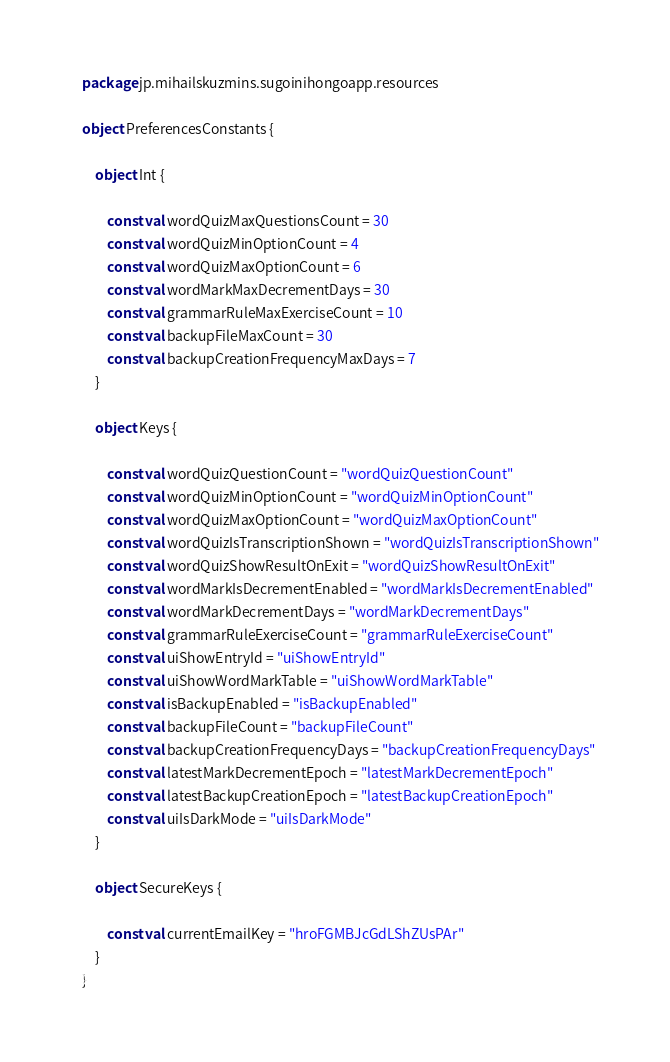Convert code to text. <code><loc_0><loc_0><loc_500><loc_500><_Kotlin_>package jp.mihailskuzmins.sugoinihongoapp.resources

object PreferencesConstants {

	object Int {

		const val wordQuizMaxQuestionsCount = 30
		const val wordQuizMinOptionCount = 4
		const val wordQuizMaxOptionCount = 6
		const val wordMarkMaxDecrementDays = 30
		const val grammarRuleMaxExerciseCount = 10
		const val backupFileMaxCount = 30
		const val backupCreationFrequencyMaxDays = 7
	}

	object Keys {

		const val wordQuizQuestionCount = "wordQuizQuestionCount"
		const val wordQuizMinOptionCount = "wordQuizMinOptionCount"
		const val wordQuizMaxOptionCount = "wordQuizMaxOptionCount"
		const val wordQuizIsTranscriptionShown = "wordQuizIsTranscriptionShown"
		const val wordQuizShowResultOnExit = "wordQuizShowResultOnExit"
		const val wordMarkIsDecrementEnabled = "wordMarkIsDecrementEnabled"
		const val wordMarkDecrementDays = "wordMarkDecrementDays"
		const val grammarRuleExerciseCount = "grammarRuleExerciseCount"
		const val uiShowEntryId = "uiShowEntryId"
		const val uiShowWordMarkTable = "uiShowWordMarkTable"
		const val isBackupEnabled = "isBackupEnabled"
		const val backupFileCount = "backupFileCount"
		const val backupCreationFrequencyDays = "backupCreationFrequencyDays"
		const val latestMarkDecrementEpoch = "latestMarkDecrementEpoch"
		const val latestBackupCreationEpoch = "latestBackupCreationEpoch"
		const val uiIsDarkMode = "uiIsDarkMode"
	}

	object SecureKeys {

		const val currentEmailKey = "hroFGMBJcGdLShZUsPAr"
	}
}</code> 